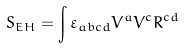<formula> <loc_0><loc_0><loc_500><loc_500>S _ { E H } = \int \varepsilon _ { a b c d } V ^ { a } V ^ { c } R ^ { c d }</formula> 